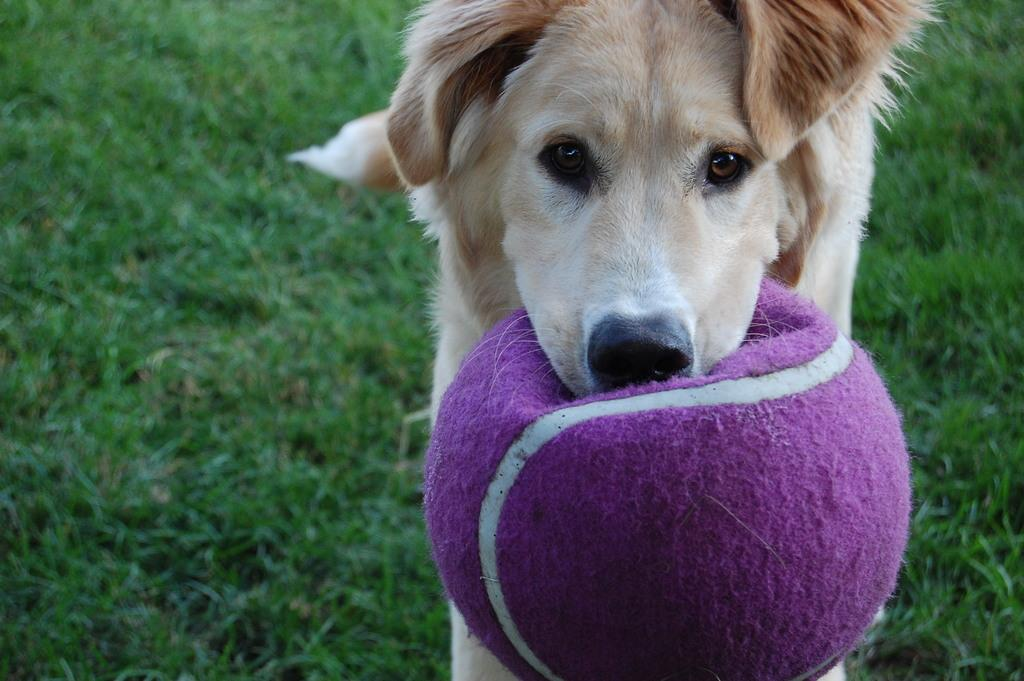What animal can be seen in the image? There is a dog in the image. What is the dog holding in its mouth? The dog is holding a pink ball in its mouth. Where is the dog standing? The dog is standing on the grass. What is the grass located on? The grass is on the ground. What type of waste is the dog wearing as a badge in the image? There is no waste or badge present on the dog in the image. How much growth has the dog experienced since the last time it was photographed? The image does not provide any information about the dog's growth or previous photographs, so it cannot be determined. 